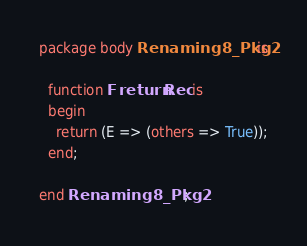<code> <loc_0><loc_0><loc_500><loc_500><_Ada_>package body Renaming8_Pkg2 is

  function F return Rec is
  begin
    return (E => (others => True));
  end;

end Renaming8_Pkg2;
</code> 